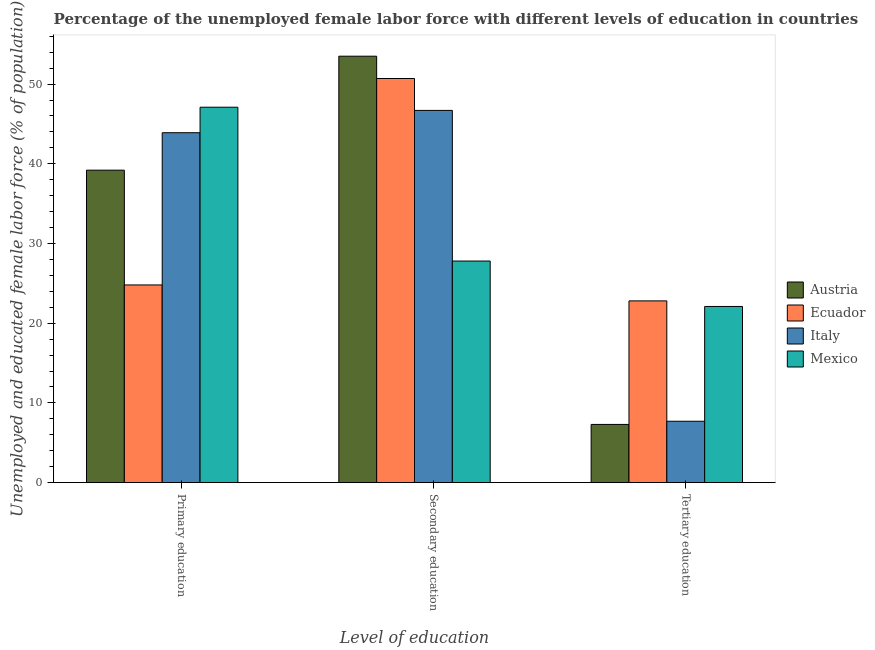Are the number of bars on each tick of the X-axis equal?
Ensure brevity in your answer.  Yes. How many bars are there on the 1st tick from the left?
Your answer should be compact. 4. How many bars are there on the 3rd tick from the right?
Ensure brevity in your answer.  4. What is the label of the 1st group of bars from the left?
Offer a very short reply. Primary education. What is the percentage of female labor force who received primary education in Austria?
Make the answer very short. 39.2. Across all countries, what is the maximum percentage of female labor force who received primary education?
Ensure brevity in your answer.  47.1. Across all countries, what is the minimum percentage of female labor force who received primary education?
Your answer should be very brief. 24.8. In which country was the percentage of female labor force who received primary education minimum?
Provide a succinct answer. Ecuador. What is the total percentage of female labor force who received secondary education in the graph?
Offer a terse response. 178.7. What is the difference between the percentage of female labor force who received secondary education in Ecuador and that in Mexico?
Ensure brevity in your answer.  22.9. What is the difference between the percentage of female labor force who received primary education in Italy and the percentage of female labor force who received secondary education in Austria?
Give a very brief answer. -9.6. What is the average percentage of female labor force who received tertiary education per country?
Your answer should be very brief. 14.97. What is the difference between the percentage of female labor force who received tertiary education and percentage of female labor force who received secondary education in Mexico?
Ensure brevity in your answer.  -5.7. What is the ratio of the percentage of female labor force who received primary education in Ecuador to that in Austria?
Your answer should be very brief. 0.63. Is the difference between the percentage of female labor force who received tertiary education in Ecuador and Mexico greater than the difference between the percentage of female labor force who received primary education in Ecuador and Mexico?
Keep it short and to the point. Yes. What is the difference between the highest and the second highest percentage of female labor force who received secondary education?
Provide a short and direct response. 2.8. What is the difference between the highest and the lowest percentage of female labor force who received secondary education?
Provide a short and direct response. 25.7. How many bars are there?
Your answer should be very brief. 12. Are all the bars in the graph horizontal?
Ensure brevity in your answer.  No. Does the graph contain any zero values?
Offer a terse response. No. How many legend labels are there?
Keep it short and to the point. 4. What is the title of the graph?
Give a very brief answer. Percentage of the unemployed female labor force with different levels of education in countries. What is the label or title of the X-axis?
Make the answer very short. Level of education. What is the label or title of the Y-axis?
Offer a very short reply. Unemployed and educated female labor force (% of population). What is the Unemployed and educated female labor force (% of population) of Austria in Primary education?
Your answer should be very brief. 39.2. What is the Unemployed and educated female labor force (% of population) in Ecuador in Primary education?
Ensure brevity in your answer.  24.8. What is the Unemployed and educated female labor force (% of population) of Italy in Primary education?
Your answer should be very brief. 43.9. What is the Unemployed and educated female labor force (% of population) in Mexico in Primary education?
Give a very brief answer. 47.1. What is the Unemployed and educated female labor force (% of population) of Austria in Secondary education?
Offer a very short reply. 53.5. What is the Unemployed and educated female labor force (% of population) in Ecuador in Secondary education?
Provide a short and direct response. 50.7. What is the Unemployed and educated female labor force (% of population) of Italy in Secondary education?
Your response must be concise. 46.7. What is the Unemployed and educated female labor force (% of population) in Mexico in Secondary education?
Make the answer very short. 27.8. What is the Unemployed and educated female labor force (% of population) in Austria in Tertiary education?
Make the answer very short. 7.3. What is the Unemployed and educated female labor force (% of population) of Ecuador in Tertiary education?
Give a very brief answer. 22.8. What is the Unemployed and educated female labor force (% of population) of Italy in Tertiary education?
Give a very brief answer. 7.7. What is the Unemployed and educated female labor force (% of population) of Mexico in Tertiary education?
Ensure brevity in your answer.  22.1. Across all Level of education, what is the maximum Unemployed and educated female labor force (% of population) of Austria?
Keep it short and to the point. 53.5. Across all Level of education, what is the maximum Unemployed and educated female labor force (% of population) of Ecuador?
Offer a very short reply. 50.7. Across all Level of education, what is the maximum Unemployed and educated female labor force (% of population) of Italy?
Your answer should be compact. 46.7. Across all Level of education, what is the maximum Unemployed and educated female labor force (% of population) in Mexico?
Provide a succinct answer. 47.1. Across all Level of education, what is the minimum Unemployed and educated female labor force (% of population) in Austria?
Your response must be concise. 7.3. Across all Level of education, what is the minimum Unemployed and educated female labor force (% of population) in Ecuador?
Provide a succinct answer. 22.8. Across all Level of education, what is the minimum Unemployed and educated female labor force (% of population) of Italy?
Your response must be concise. 7.7. Across all Level of education, what is the minimum Unemployed and educated female labor force (% of population) in Mexico?
Keep it short and to the point. 22.1. What is the total Unemployed and educated female labor force (% of population) in Ecuador in the graph?
Provide a succinct answer. 98.3. What is the total Unemployed and educated female labor force (% of population) of Italy in the graph?
Your answer should be compact. 98.3. What is the total Unemployed and educated female labor force (% of population) in Mexico in the graph?
Provide a short and direct response. 97. What is the difference between the Unemployed and educated female labor force (% of population) in Austria in Primary education and that in Secondary education?
Provide a short and direct response. -14.3. What is the difference between the Unemployed and educated female labor force (% of population) in Ecuador in Primary education and that in Secondary education?
Ensure brevity in your answer.  -25.9. What is the difference between the Unemployed and educated female labor force (% of population) in Italy in Primary education and that in Secondary education?
Keep it short and to the point. -2.8. What is the difference between the Unemployed and educated female labor force (% of population) in Mexico in Primary education and that in Secondary education?
Your response must be concise. 19.3. What is the difference between the Unemployed and educated female labor force (% of population) of Austria in Primary education and that in Tertiary education?
Ensure brevity in your answer.  31.9. What is the difference between the Unemployed and educated female labor force (% of population) in Italy in Primary education and that in Tertiary education?
Give a very brief answer. 36.2. What is the difference between the Unemployed and educated female labor force (% of population) in Mexico in Primary education and that in Tertiary education?
Provide a succinct answer. 25. What is the difference between the Unemployed and educated female labor force (% of population) of Austria in Secondary education and that in Tertiary education?
Make the answer very short. 46.2. What is the difference between the Unemployed and educated female labor force (% of population) of Ecuador in Secondary education and that in Tertiary education?
Provide a succinct answer. 27.9. What is the difference between the Unemployed and educated female labor force (% of population) of Italy in Secondary education and that in Tertiary education?
Give a very brief answer. 39. What is the difference between the Unemployed and educated female labor force (% of population) of Austria in Primary education and the Unemployed and educated female labor force (% of population) of Ecuador in Secondary education?
Your response must be concise. -11.5. What is the difference between the Unemployed and educated female labor force (% of population) in Austria in Primary education and the Unemployed and educated female labor force (% of population) in Mexico in Secondary education?
Keep it short and to the point. 11.4. What is the difference between the Unemployed and educated female labor force (% of population) in Ecuador in Primary education and the Unemployed and educated female labor force (% of population) in Italy in Secondary education?
Your answer should be compact. -21.9. What is the difference between the Unemployed and educated female labor force (% of population) of Ecuador in Primary education and the Unemployed and educated female labor force (% of population) of Mexico in Secondary education?
Give a very brief answer. -3. What is the difference between the Unemployed and educated female labor force (% of population) in Italy in Primary education and the Unemployed and educated female labor force (% of population) in Mexico in Secondary education?
Your answer should be compact. 16.1. What is the difference between the Unemployed and educated female labor force (% of population) in Austria in Primary education and the Unemployed and educated female labor force (% of population) in Ecuador in Tertiary education?
Give a very brief answer. 16.4. What is the difference between the Unemployed and educated female labor force (% of population) of Austria in Primary education and the Unemployed and educated female labor force (% of population) of Italy in Tertiary education?
Make the answer very short. 31.5. What is the difference between the Unemployed and educated female labor force (% of population) in Austria in Primary education and the Unemployed and educated female labor force (% of population) in Mexico in Tertiary education?
Your answer should be very brief. 17.1. What is the difference between the Unemployed and educated female labor force (% of population) of Ecuador in Primary education and the Unemployed and educated female labor force (% of population) of Italy in Tertiary education?
Your response must be concise. 17.1. What is the difference between the Unemployed and educated female labor force (% of population) of Italy in Primary education and the Unemployed and educated female labor force (% of population) of Mexico in Tertiary education?
Ensure brevity in your answer.  21.8. What is the difference between the Unemployed and educated female labor force (% of population) of Austria in Secondary education and the Unemployed and educated female labor force (% of population) of Ecuador in Tertiary education?
Your answer should be compact. 30.7. What is the difference between the Unemployed and educated female labor force (% of population) in Austria in Secondary education and the Unemployed and educated female labor force (% of population) in Italy in Tertiary education?
Ensure brevity in your answer.  45.8. What is the difference between the Unemployed and educated female labor force (% of population) in Austria in Secondary education and the Unemployed and educated female labor force (% of population) in Mexico in Tertiary education?
Make the answer very short. 31.4. What is the difference between the Unemployed and educated female labor force (% of population) of Ecuador in Secondary education and the Unemployed and educated female labor force (% of population) of Italy in Tertiary education?
Offer a terse response. 43. What is the difference between the Unemployed and educated female labor force (% of population) of Ecuador in Secondary education and the Unemployed and educated female labor force (% of population) of Mexico in Tertiary education?
Provide a succinct answer. 28.6. What is the difference between the Unemployed and educated female labor force (% of population) in Italy in Secondary education and the Unemployed and educated female labor force (% of population) in Mexico in Tertiary education?
Your response must be concise. 24.6. What is the average Unemployed and educated female labor force (% of population) in Austria per Level of education?
Provide a succinct answer. 33.33. What is the average Unemployed and educated female labor force (% of population) in Ecuador per Level of education?
Provide a succinct answer. 32.77. What is the average Unemployed and educated female labor force (% of population) in Italy per Level of education?
Your response must be concise. 32.77. What is the average Unemployed and educated female labor force (% of population) of Mexico per Level of education?
Ensure brevity in your answer.  32.33. What is the difference between the Unemployed and educated female labor force (% of population) in Austria and Unemployed and educated female labor force (% of population) in Mexico in Primary education?
Offer a terse response. -7.9. What is the difference between the Unemployed and educated female labor force (% of population) of Ecuador and Unemployed and educated female labor force (% of population) of Italy in Primary education?
Offer a very short reply. -19.1. What is the difference between the Unemployed and educated female labor force (% of population) of Ecuador and Unemployed and educated female labor force (% of population) of Mexico in Primary education?
Ensure brevity in your answer.  -22.3. What is the difference between the Unemployed and educated female labor force (% of population) in Italy and Unemployed and educated female labor force (% of population) in Mexico in Primary education?
Provide a succinct answer. -3.2. What is the difference between the Unemployed and educated female labor force (% of population) in Austria and Unemployed and educated female labor force (% of population) in Ecuador in Secondary education?
Make the answer very short. 2.8. What is the difference between the Unemployed and educated female labor force (% of population) of Austria and Unemployed and educated female labor force (% of population) of Mexico in Secondary education?
Your answer should be compact. 25.7. What is the difference between the Unemployed and educated female labor force (% of population) in Ecuador and Unemployed and educated female labor force (% of population) in Mexico in Secondary education?
Provide a short and direct response. 22.9. What is the difference between the Unemployed and educated female labor force (% of population) of Italy and Unemployed and educated female labor force (% of population) of Mexico in Secondary education?
Keep it short and to the point. 18.9. What is the difference between the Unemployed and educated female labor force (% of population) in Austria and Unemployed and educated female labor force (% of population) in Ecuador in Tertiary education?
Give a very brief answer. -15.5. What is the difference between the Unemployed and educated female labor force (% of population) in Austria and Unemployed and educated female labor force (% of population) in Italy in Tertiary education?
Your answer should be very brief. -0.4. What is the difference between the Unemployed and educated female labor force (% of population) in Austria and Unemployed and educated female labor force (% of population) in Mexico in Tertiary education?
Your answer should be very brief. -14.8. What is the difference between the Unemployed and educated female labor force (% of population) in Ecuador and Unemployed and educated female labor force (% of population) in Italy in Tertiary education?
Your answer should be compact. 15.1. What is the difference between the Unemployed and educated female labor force (% of population) of Ecuador and Unemployed and educated female labor force (% of population) of Mexico in Tertiary education?
Your answer should be very brief. 0.7. What is the difference between the Unemployed and educated female labor force (% of population) of Italy and Unemployed and educated female labor force (% of population) of Mexico in Tertiary education?
Make the answer very short. -14.4. What is the ratio of the Unemployed and educated female labor force (% of population) of Austria in Primary education to that in Secondary education?
Offer a very short reply. 0.73. What is the ratio of the Unemployed and educated female labor force (% of population) in Ecuador in Primary education to that in Secondary education?
Your answer should be very brief. 0.49. What is the ratio of the Unemployed and educated female labor force (% of population) in Mexico in Primary education to that in Secondary education?
Offer a very short reply. 1.69. What is the ratio of the Unemployed and educated female labor force (% of population) of Austria in Primary education to that in Tertiary education?
Offer a terse response. 5.37. What is the ratio of the Unemployed and educated female labor force (% of population) of Ecuador in Primary education to that in Tertiary education?
Offer a terse response. 1.09. What is the ratio of the Unemployed and educated female labor force (% of population) of Italy in Primary education to that in Tertiary education?
Give a very brief answer. 5.7. What is the ratio of the Unemployed and educated female labor force (% of population) of Mexico in Primary education to that in Tertiary education?
Offer a very short reply. 2.13. What is the ratio of the Unemployed and educated female labor force (% of population) in Austria in Secondary education to that in Tertiary education?
Give a very brief answer. 7.33. What is the ratio of the Unemployed and educated female labor force (% of population) in Ecuador in Secondary education to that in Tertiary education?
Provide a succinct answer. 2.22. What is the ratio of the Unemployed and educated female labor force (% of population) in Italy in Secondary education to that in Tertiary education?
Your answer should be very brief. 6.06. What is the ratio of the Unemployed and educated female labor force (% of population) of Mexico in Secondary education to that in Tertiary education?
Give a very brief answer. 1.26. What is the difference between the highest and the second highest Unemployed and educated female labor force (% of population) in Austria?
Your response must be concise. 14.3. What is the difference between the highest and the second highest Unemployed and educated female labor force (% of population) in Ecuador?
Your answer should be very brief. 25.9. What is the difference between the highest and the second highest Unemployed and educated female labor force (% of population) of Italy?
Ensure brevity in your answer.  2.8. What is the difference between the highest and the second highest Unemployed and educated female labor force (% of population) in Mexico?
Provide a succinct answer. 19.3. What is the difference between the highest and the lowest Unemployed and educated female labor force (% of population) of Austria?
Offer a terse response. 46.2. What is the difference between the highest and the lowest Unemployed and educated female labor force (% of population) of Ecuador?
Your answer should be compact. 27.9. 